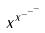<formula> <loc_0><loc_0><loc_500><loc_500>x ^ { x ^ { - ^ { - ^ { - } } } }</formula> 